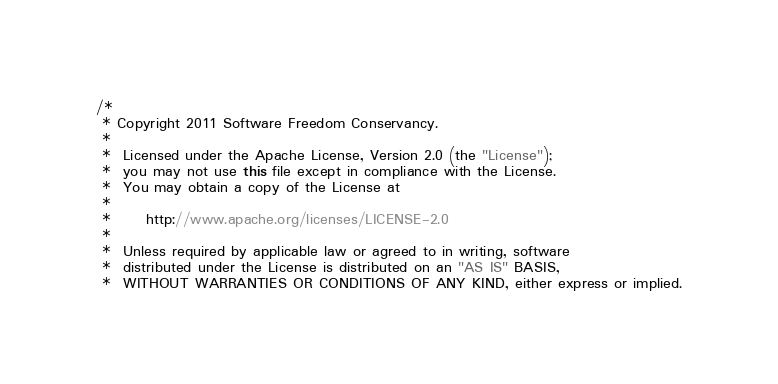<code> <loc_0><loc_0><loc_500><loc_500><_Java_>/*
 * Copyright 2011 Software Freedom Conservancy.
 *
 *  Licensed under the Apache License, Version 2.0 (the "License");
 *  you may not use this file except in compliance with the License.
 *  You may obtain a copy of the License at
 *
 *      http://www.apache.org/licenses/LICENSE-2.0
 *
 *  Unless required by applicable law or agreed to in writing, software
 *  distributed under the License is distributed on an "AS IS" BASIS,
 *  WITHOUT WARRANTIES OR CONDITIONS OF ANY KIND, either express or implied.</code> 